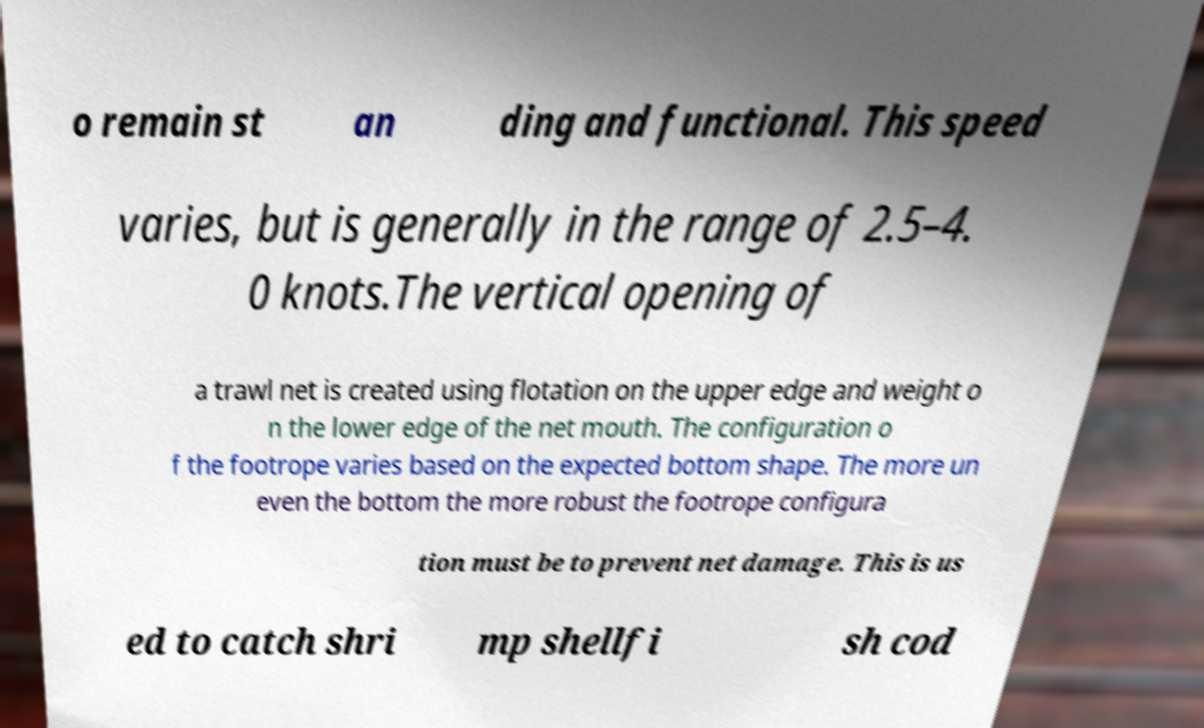For documentation purposes, I need the text within this image transcribed. Could you provide that? o remain st an ding and functional. This speed varies, but is generally in the range of 2.5–4. 0 knots.The vertical opening of a trawl net is created using flotation on the upper edge and weight o n the lower edge of the net mouth. The configuration o f the footrope varies based on the expected bottom shape. The more un even the bottom the more robust the footrope configura tion must be to prevent net damage. This is us ed to catch shri mp shellfi sh cod 